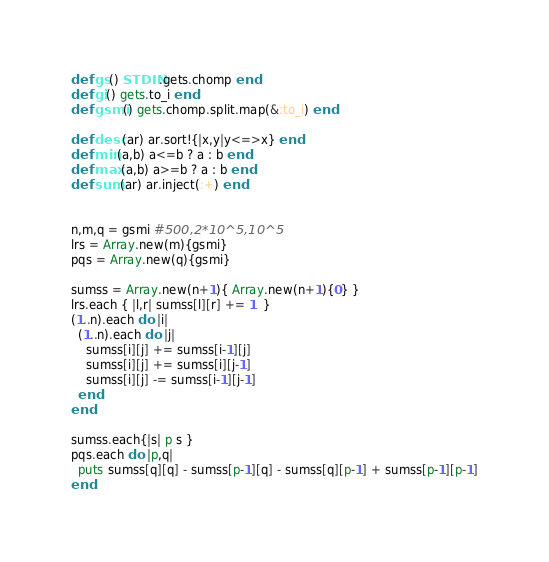Convert code to text. <code><loc_0><loc_0><loc_500><loc_500><_Ruby_>def gs() STDIN.gets.chomp end
def gi() gets.to_i end
def gsmi() gets.chomp.split.map(&:to_i) end

def desc(ar) ar.sort!{|x,y|y<=>x} end
def min(a,b) a<=b ? a : b end
def max(a,b) a>=b ? a : b end
def sum(ar) ar.inject(:+) end


n,m,q = gsmi #500,2*10^5,10^5
lrs = Array.new(m){gsmi}
pqs = Array.new(q){gsmi}

sumss = Array.new(n+1){ Array.new(n+1){0} }
lrs.each { |l,r| sumss[l][r] += 1  }
(1..n).each do |i|
  (1..n).each do |j|
    sumss[i][j] += sumss[i-1][j]
    sumss[i][j] += sumss[i][j-1]
    sumss[i][j] -= sumss[i-1][j-1]
  end
end

sumss.each{|s| p s }
pqs.each do |p,q|
  puts sumss[q][q] - sumss[p-1][q] - sumss[q][p-1] + sumss[p-1][p-1]
end
</code> 